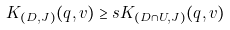<formula> <loc_0><loc_0><loc_500><loc_500>K _ { ( D , J ) } ( q , v ) \geq s K _ { ( D \cap U , J ) } ( q , v )</formula> 